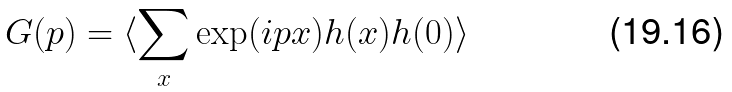<formula> <loc_0><loc_0><loc_500><loc_500>G ( p ) = \langle \sum _ { x } \exp ( i p x ) h ( x ) h ( 0 ) \rangle</formula> 